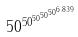Convert formula to latex. <formula><loc_0><loc_0><loc_500><loc_500>5 0 ^ { 5 0 ^ { 5 0 ^ { 5 0 ^ { 5 0 ^ { 6 . 8 3 9 } } } } }</formula> 